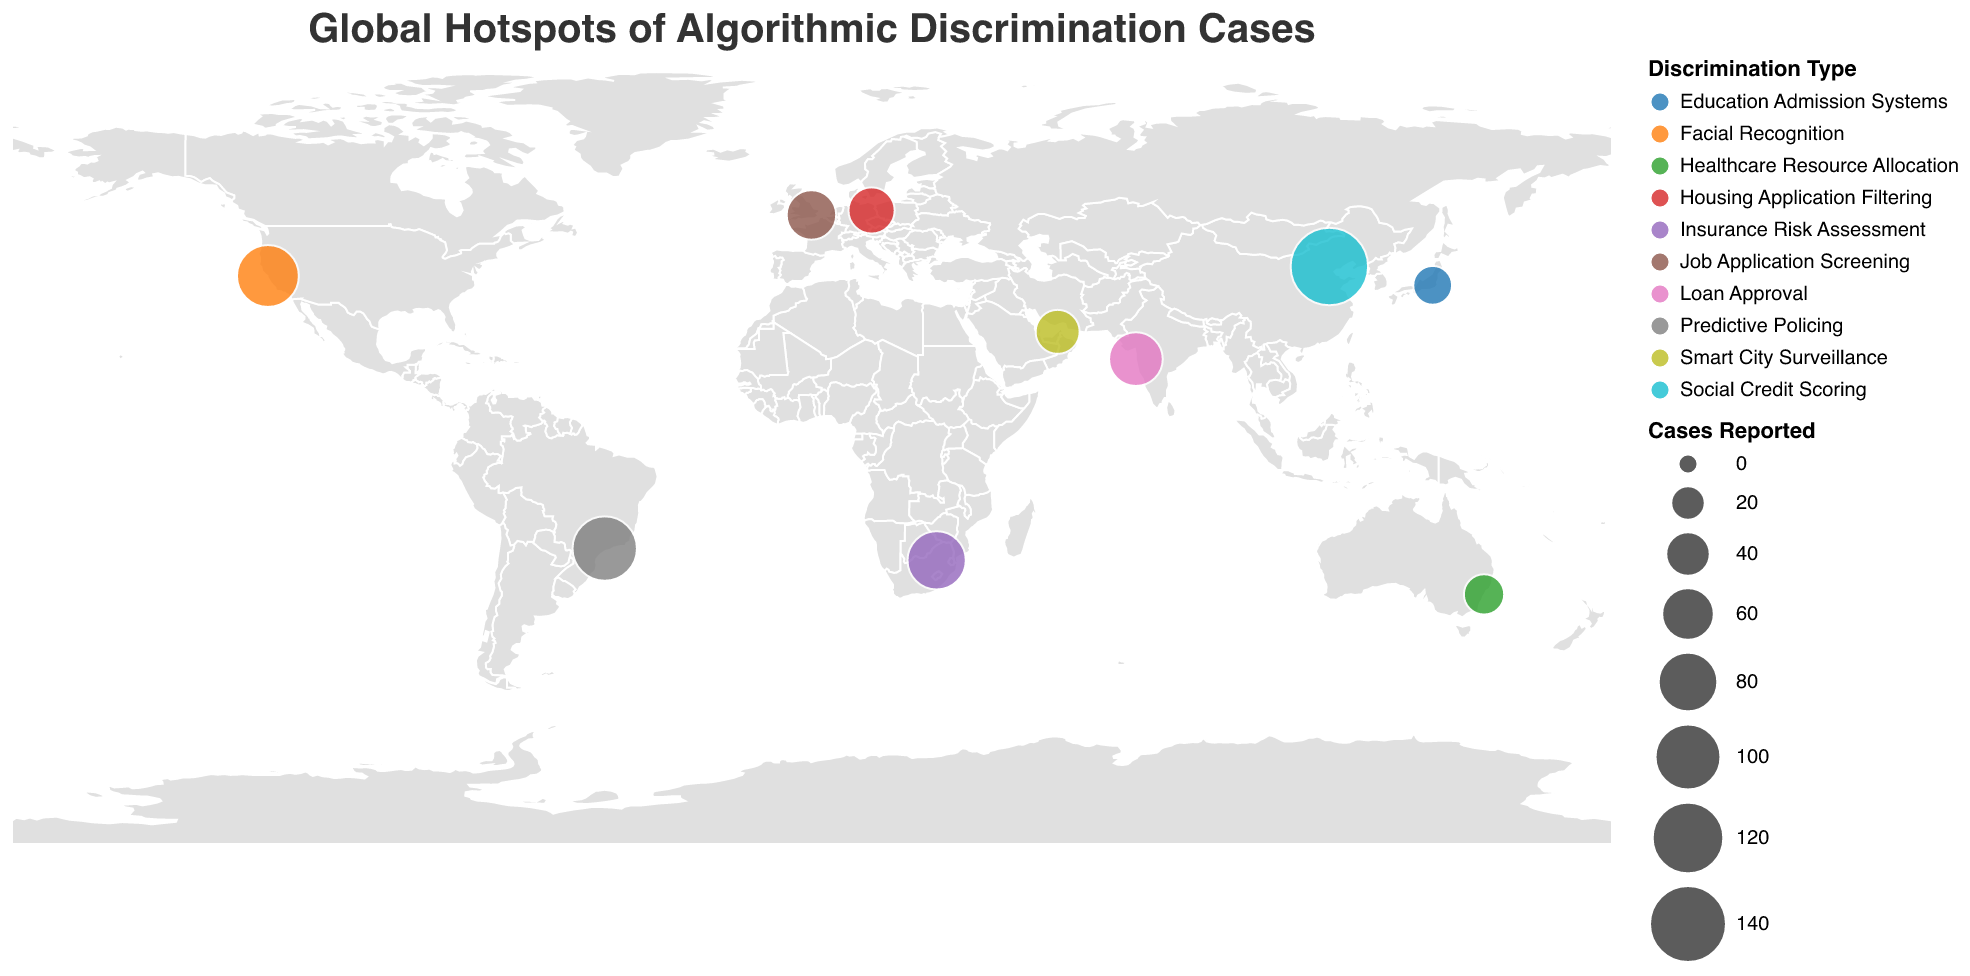What is the title of the figure? The title is usually displayed at the top of the figure. Here, it is clearly stated as "Global Hotspots of Algorithmic Discrimination Cases."
Answer: Global Hotspots of Algorithmic Discrimination Cases Which city has reported the highest number of algorithmic discrimination cases? By looking at the size of the circles, the largest circle represents the city with the most cases. In this figure, Beijing has the largest circle with 142 cases reported.
Answer: Beijing How many algorithmic discrimination cases have been reported in London? Hover over the point representing London and look at the tooltip. It shows 52 cases reported for London.
Answer: 52 What are the different types of algorithmic discrimination indicated in the figure? By examining the color legend on the figure, we can see the various discrimination types listed. They include Facial Recognition, Social Credit Scoring, Loan Approval, Job Application Screening, Predictive Policing, Healthcare Resource Allocation, Housing Application Filtering, Education Admission Systems, Insurance Risk Assessment, and Smart City Surveillance.
Answer: Facial Recognition, Social Credit Scoring, Loan Approval, Job Application Screening, Predictive Policing, Healthcare Resource Allocation, Housing Application Filtering, Education Admission Systems, Insurance Risk Assessment, Smart City Surveillance Which city in India is reporting algorithmic discrimination and what type of discrimination is prevalent there? Locate the point representing a city in India on the map and look at the tooltip; it shows that Mumbai is reporting Loan Approval discrimination.
Answer: Mumbai, Loan Approval How does the number of cases in San Francisco compare to those in Sao Paulo? San Francisco has 87 cases and Sao Paulo has 95. By comparing the numbers, Sao Paulo has slightly more cases than San Francisco.
Answer: Sao Paulo has more cases What is the socioeconomic context in Sydney where 31 algorithmic discrimination cases have been reported? Hover over the point in Sydney and read the tooltip; it states the context as "Developed economy with universal healthcare system."
Answer: Developed economy with universal healthcare system How many cities reported cases of algorithmic discrimination related to Predictive Policing, and which are they? Check the color associated with Predictive Policing in the legend and then find the corresponding points on the map. Sao Paulo is the city with Predictive Policing discrimination.
Answer: One city, Sao Paulo Which type of discrimination has the least reported cases and in which city? By looking at the smallest circle and verifying with the tooltip, Tokyo has the least number of cases (28) related to Education Admission Systems.
Answer: Education Admission Systems, Tokyo 